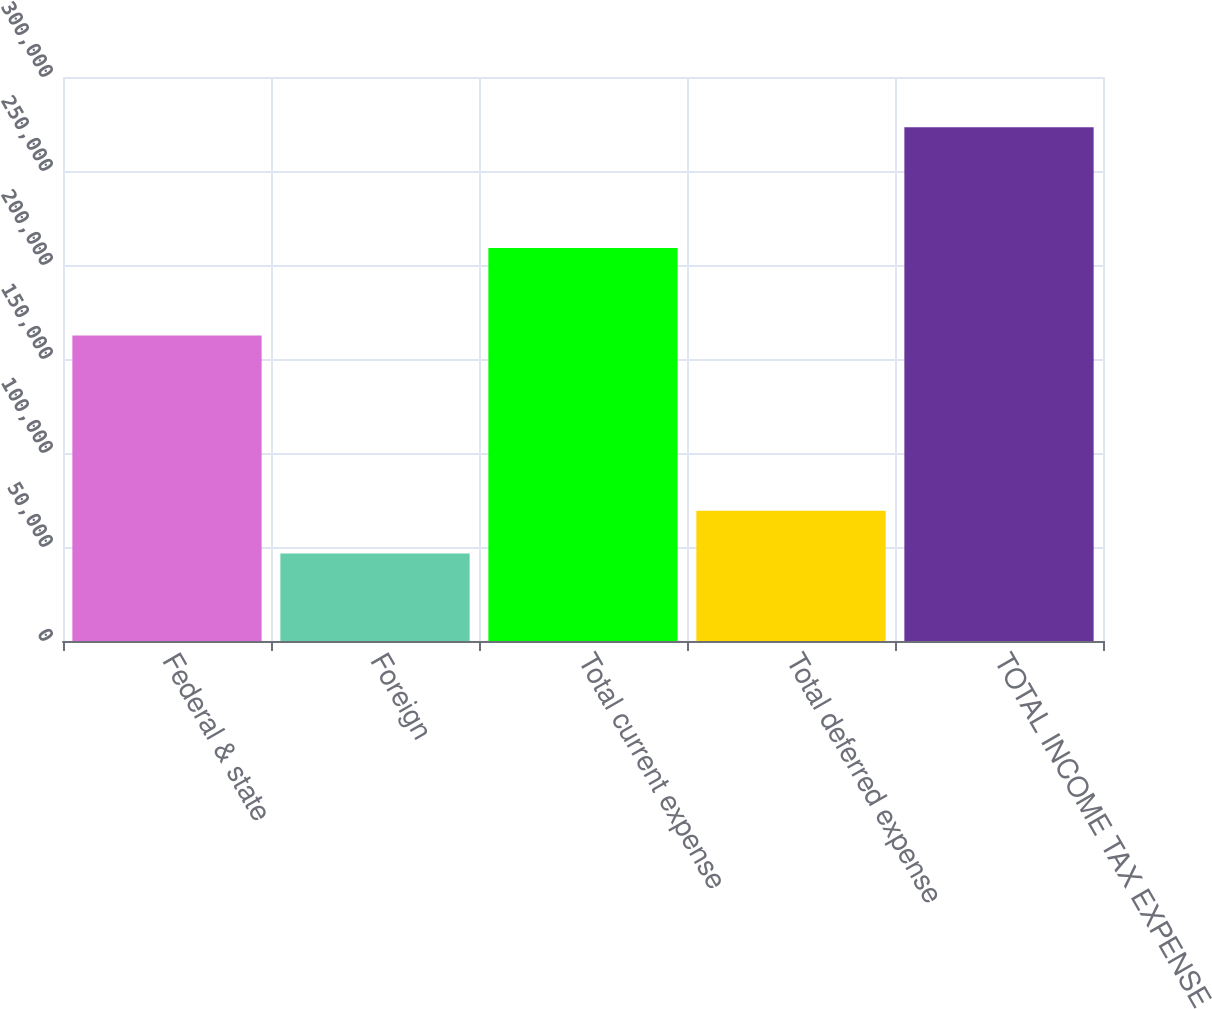<chart> <loc_0><loc_0><loc_500><loc_500><bar_chart><fcel>Federal & state<fcel>Foreign<fcel>Total current expense<fcel>Total deferred expense<fcel>TOTAL INCOME TAX EXPENSE<nl><fcel>162483<fcel>46593<fcel>209076<fcel>69256.7<fcel>273230<nl></chart> 